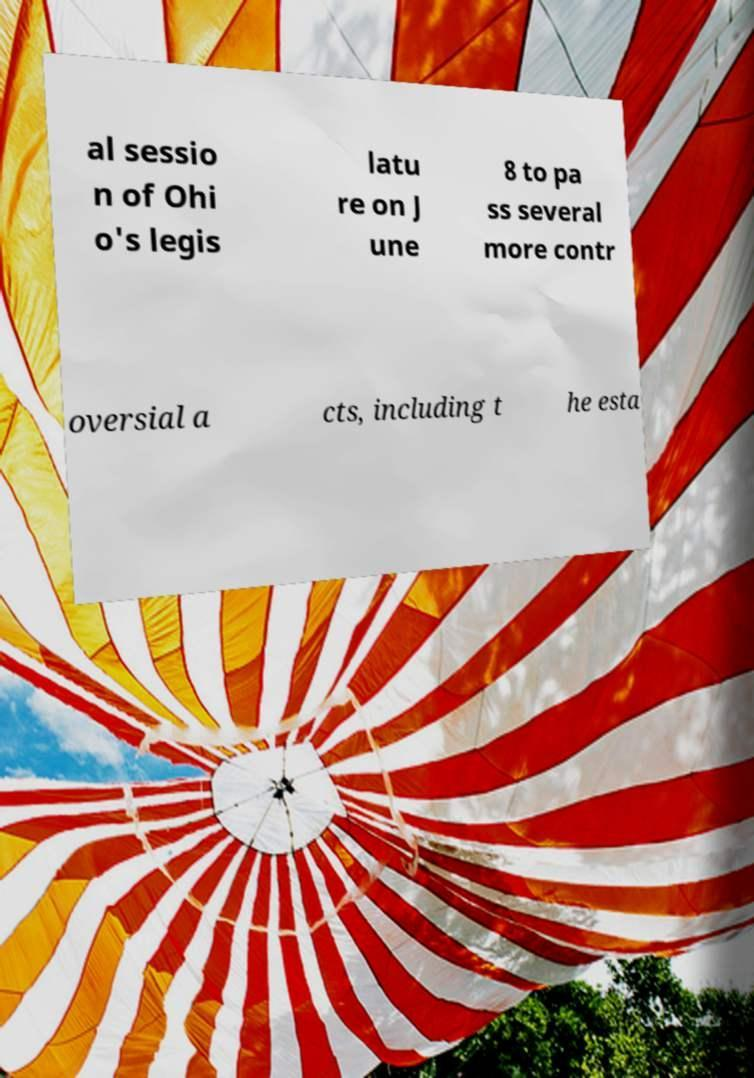Can you accurately transcribe the text from the provided image for me? al sessio n of Ohi o's legis latu re on J une 8 to pa ss several more contr oversial a cts, including t he esta 